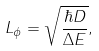<formula> <loc_0><loc_0><loc_500><loc_500>L _ { \phi } = \sqrt { \frac { \hbar { D } } { \Delta E } } ,</formula> 